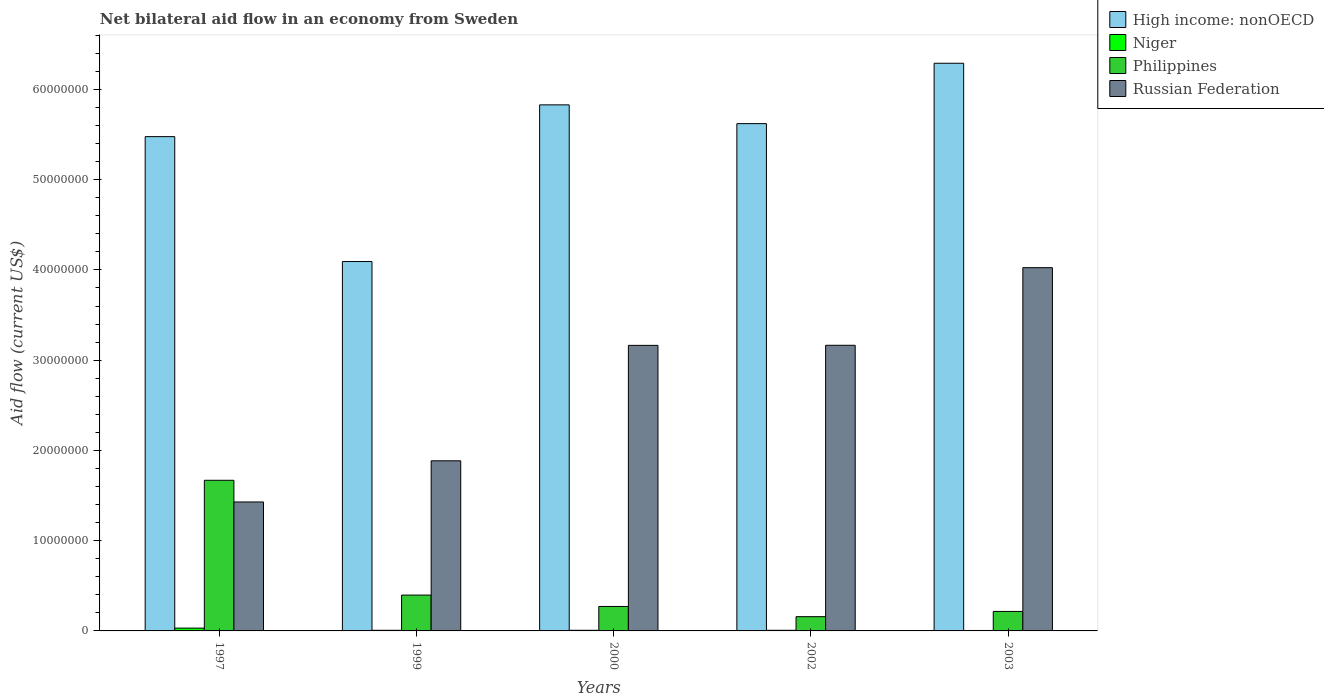In how many cases, is the number of bars for a given year not equal to the number of legend labels?
Your response must be concise. 0. What is the net bilateral aid flow in Russian Federation in 2002?
Give a very brief answer. 3.16e+07. Across all years, what is the maximum net bilateral aid flow in Russian Federation?
Your answer should be very brief. 4.02e+07. Across all years, what is the minimum net bilateral aid flow in Philippines?
Offer a terse response. 1.58e+06. In which year was the net bilateral aid flow in Niger minimum?
Provide a short and direct response. 2003. What is the total net bilateral aid flow in Philippines in the graph?
Offer a terse response. 2.71e+07. What is the difference between the net bilateral aid flow in High income: nonOECD in 1997 and that in 2002?
Your answer should be compact. -1.44e+06. What is the difference between the net bilateral aid flow in Russian Federation in 2000 and the net bilateral aid flow in Philippines in 2003?
Ensure brevity in your answer.  2.95e+07. What is the average net bilateral aid flow in Russian Federation per year?
Keep it short and to the point. 2.73e+07. In the year 2002, what is the difference between the net bilateral aid flow in Niger and net bilateral aid flow in High income: nonOECD?
Give a very brief answer. -5.61e+07. In how many years, is the net bilateral aid flow in Philippines greater than 18000000 US$?
Your answer should be very brief. 0. What is the ratio of the net bilateral aid flow in Russian Federation in 2000 to that in 2003?
Offer a very short reply. 0.79. What is the difference between the highest and the second highest net bilateral aid flow in Russian Federation?
Your response must be concise. 8.60e+06. What is the difference between the highest and the lowest net bilateral aid flow in High income: nonOECD?
Offer a terse response. 2.20e+07. Is the sum of the net bilateral aid flow in Russian Federation in 2002 and 2003 greater than the maximum net bilateral aid flow in Niger across all years?
Provide a succinct answer. Yes. What does the 1st bar from the left in 1997 represents?
Your answer should be very brief. High income: nonOECD. How many bars are there?
Ensure brevity in your answer.  20. What is the difference between two consecutive major ticks on the Y-axis?
Keep it short and to the point. 1.00e+07. Are the values on the major ticks of Y-axis written in scientific E-notation?
Give a very brief answer. No. Does the graph contain any zero values?
Give a very brief answer. No. Does the graph contain grids?
Offer a terse response. No. Where does the legend appear in the graph?
Provide a succinct answer. Top right. What is the title of the graph?
Offer a terse response. Net bilateral aid flow in an economy from Sweden. What is the Aid flow (current US$) in High income: nonOECD in 1997?
Keep it short and to the point. 5.48e+07. What is the Aid flow (current US$) in Niger in 1997?
Your answer should be compact. 3.10e+05. What is the Aid flow (current US$) in Philippines in 1997?
Keep it short and to the point. 1.67e+07. What is the Aid flow (current US$) of Russian Federation in 1997?
Your response must be concise. 1.43e+07. What is the Aid flow (current US$) in High income: nonOECD in 1999?
Keep it short and to the point. 4.09e+07. What is the Aid flow (current US$) of Philippines in 1999?
Provide a succinct answer. 3.97e+06. What is the Aid flow (current US$) in Russian Federation in 1999?
Keep it short and to the point. 1.88e+07. What is the Aid flow (current US$) of High income: nonOECD in 2000?
Offer a very short reply. 5.83e+07. What is the Aid flow (current US$) of Philippines in 2000?
Provide a short and direct response. 2.71e+06. What is the Aid flow (current US$) of Russian Federation in 2000?
Give a very brief answer. 3.16e+07. What is the Aid flow (current US$) of High income: nonOECD in 2002?
Ensure brevity in your answer.  5.62e+07. What is the Aid flow (current US$) of Niger in 2002?
Your answer should be very brief. 7.00e+04. What is the Aid flow (current US$) in Philippines in 2002?
Your response must be concise. 1.58e+06. What is the Aid flow (current US$) of Russian Federation in 2002?
Make the answer very short. 3.16e+07. What is the Aid flow (current US$) in High income: nonOECD in 2003?
Your answer should be compact. 6.29e+07. What is the Aid flow (current US$) in Niger in 2003?
Ensure brevity in your answer.  5.00e+04. What is the Aid flow (current US$) of Philippines in 2003?
Provide a succinct answer. 2.16e+06. What is the Aid flow (current US$) in Russian Federation in 2003?
Offer a terse response. 4.02e+07. Across all years, what is the maximum Aid flow (current US$) in High income: nonOECD?
Offer a terse response. 6.29e+07. Across all years, what is the maximum Aid flow (current US$) in Philippines?
Your answer should be compact. 1.67e+07. Across all years, what is the maximum Aid flow (current US$) of Russian Federation?
Ensure brevity in your answer.  4.02e+07. Across all years, what is the minimum Aid flow (current US$) in High income: nonOECD?
Your answer should be compact. 4.09e+07. Across all years, what is the minimum Aid flow (current US$) of Niger?
Offer a very short reply. 5.00e+04. Across all years, what is the minimum Aid flow (current US$) in Philippines?
Your answer should be very brief. 1.58e+06. Across all years, what is the minimum Aid flow (current US$) of Russian Federation?
Offer a very short reply. 1.43e+07. What is the total Aid flow (current US$) in High income: nonOECD in the graph?
Ensure brevity in your answer.  2.73e+08. What is the total Aid flow (current US$) in Niger in the graph?
Provide a short and direct response. 5.70e+05. What is the total Aid flow (current US$) in Philippines in the graph?
Keep it short and to the point. 2.71e+07. What is the total Aid flow (current US$) in Russian Federation in the graph?
Keep it short and to the point. 1.37e+08. What is the difference between the Aid flow (current US$) of High income: nonOECD in 1997 and that in 1999?
Ensure brevity in your answer.  1.38e+07. What is the difference between the Aid flow (current US$) of Philippines in 1997 and that in 1999?
Offer a very short reply. 1.27e+07. What is the difference between the Aid flow (current US$) in Russian Federation in 1997 and that in 1999?
Provide a succinct answer. -4.56e+06. What is the difference between the Aid flow (current US$) in High income: nonOECD in 1997 and that in 2000?
Offer a very short reply. -3.52e+06. What is the difference between the Aid flow (current US$) in Niger in 1997 and that in 2000?
Your answer should be compact. 2.40e+05. What is the difference between the Aid flow (current US$) of Philippines in 1997 and that in 2000?
Offer a terse response. 1.40e+07. What is the difference between the Aid flow (current US$) of Russian Federation in 1997 and that in 2000?
Offer a terse response. -1.74e+07. What is the difference between the Aid flow (current US$) of High income: nonOECD in 1997 and that in 2002?
Your response must be concise. -1.44e+06. What is the difference between the Aid flow (current US$) in Philippines in 1997 and that in 2002?
Your response must be concise. 1.51e+07. What is the difference between the Aid flow (current US$) of Russian Federation in 1997 and that in 2002?
Keep it short and to the point. -1.74e+07. What is the difference between the Aid flow (current US$) in High income: nonOECD in 1997 and that in 2003?
Provide a short and direct response. -8.13e+06. What is the difference between the Aid flow (current US$) in Philippines in 1997 and that in 2003?
Give a very brief answer. 1.45e+07. What is the difference between the Aid flow (current US$) in Russian Federation in 1997 and that in 2003?
Your response must be concise. -2.60e+07. What is the difference between the Aid flow (current US$) in High income: nonOECD in 1999 and that in 2000?
Provide a succinct answer. -1.74e+07. What is the difference between the Aid flow (current US$) of Philippines in 1999 and that in 2000?
Keep it short and to the point. 1.26e+06. What is the difference between the Aid flow (current US$) in Russian Federation in 1999 and that in 2000?
Give a very brief answer. -1.28e+07. What is the difference between the Aid flow (current US$) in High income: nonOECD in 1999 and that in 2002?
Your answer should be compact. -1.53e+07. What is the difference between the Aid flow (current US$) in Niger in 1999 and that in 2002?
Offer a terse response. 0. What is the difference between the Aid flow (current US$) of Philippines in 1999 and that in 2002?
Provide a succinct answer. 2.39e+06. What is the difference between the Aid flow (current US$) in Russian Federation in 1999 and that in 2002?
Your answer should be very brief. -1.28e+07. What is the difference between the Aid flow (current US$) in High income: nonOECD in 1999 and that in 2003?
Keep it short and to the point. -2.20e+07. What is the difference between the Aid flow (current US$) in Niger in 1999 and that in 2003?
Give a very brief answer. 2.00e+04. What is the difference between the Aid flow (current US$) in Philippines in 1999 and that in 2003?
Offer a terse response. 1.81e+06. What is the difference between the Aid flow (current US$) in Russian Federation in 1999 and that in 2003?
Make the answer very short. -2.14e+07. What is the difference between the Aid flow (current US$) of High income: nonOECD in 2000 and that in 2002?
Offer a very short reply. 2.08e+06. What is the difference between the Aid flow (current US$) in Philippines in 2000 and that in 2002?
Offer a very short reply. 1.13e+06. What is the difference between the Aid flow (current US$) of High income: nonOECD in 2000 and that in 2003?
Your answer should be compact. -4.61e+06. What is the difference between the Aid flow (current US$) in Niger in 2000 and that in 2003?
Make the answer very short. 2.00e+04. What is the difference between the Aid flow (current US$) of Philippines in 2000 and that in 2003?
Give a very brief answer. 5.50e+05. What is the difference between the Aid flow (current US$) in Russian Federation in 2000 and that in 2003?
Make the answer very short. -8.61e+06. What is the difference between the Aid flow (current US$) in High income: nonOECD in 2002 and that in 2003?
Offer a terse response. -6.69e+06. What is the difference between the Aid flow (current US$) of Niger in 2002 and that in 2003?
Your answer should be compact. 2.00e+04. What is the difference between the Aid flow (current US$) of Philippines in 2002 and that in 2003?
Ensure brevity in your answer.  -5.80e+05. What is the difference between the Aid flow (current US$) of Russian Federation in 2002 and that in 2003?
Your response must be concise. -8.60e+06. What is the difference between the Aid flow (current US$) in High income: nonOECD in 1997 and the Aid flow (current US$) in Niger in 1999?
Offer a terse response. 5.47e+07. What is the difference between the Aid flow (current US$) in High income: nonOECD in 1997 and the Aid flow (current US$) in Philippines in 1999?
Make the answer very short. 5.08e+07. What is the difference between the Aid flow (current US$) in High income: nonOECD in 1997 and the Aid flow (current US$) in Russian Federation in 1999?
Make the answer very short. 3.59e+07. What is the difference between the Aid flow (current US$) of Niger in 1997 and the Aid flow (current US$) of Philippines in 1999?
Your answer should be very brief. -3.66e+06. What is the difference between the Aid flow (current US$) in Niger in 1997 and the Aid flow (current US$) in Russian Federation in 1999?
Your answer should be compact. -1.85e+07. What is the difference between the Aid flow (current US$) in Philippines in 1997 and the Aid flow (current US$) in Russian Federation in 1999?
Keep it short and to the point. -2.16e+06. What is the difference between the Aid flow (current US$) in High income: nonOECD in 1997 and the Aid flow (current US$) in Niger in 2000?
Keep it short and to the point. 5.47e+07. What is the difference between the Aid flow (current US$) of High income: nonOECD in 1997 and the Aid flow (current US$) of Philippines in 2000?
Offer a terse response. 5.21e+07. What is the difference between the Aid flow (current US$) of High income: nonOECD in 1997 and the Aid flow (current US$) of Russian Federation in 2000?
Give a very brief answer. 2.31e+07. What is the difference between the Aid flow (current US$) of Niger in 1997 and the Aid flow (current US$) of Philippines in 2000?
Provide a succinct answer. -2.40e+06. What is the difference between the Aid flow (current US$) of Niger in 1997 and the Aid flow (current US$) of Russian Federation in 2000?
Offer a very short reply. -3.13e+07. What is the difference between the Aid flow (current US$) in Philippines in 1997 and the Aid flow (current US$) in Russian Federation in 2000?
Offer a very short reply. -1.50e+07. What is the difference between the Aid flow (current US$) of High income: nonOECD in 1997 and the Aid flow (current US$) of Niger in 2002?
Give a very brief answer. 5.47e+07. What is the difference between the Aid flow (current US$) in High income: nonOECD in 1997 and the Aid flow (current US$) in Philippines in 2002?
Make the answer very short. 5.32e+07. What is the difference between the Aid flow (current US$) of High income: nonOECD in 1997 and the Aid flow (current US$) of Russian Federation in 2002?
Your answer should be very brief. 2.31e+07. What is the difference between the Aid flow (current US$) of Niger in 1997 and the Aid flow (current US$) of Philippines in 2002?
Offer a terse response. -1.27e+06. What is the difference between the Aid flow (current US$) in Niger in 1997 and the Aid flow (current US$) in Russian Federation in 2002?
Your answer should be compact. -3.13e+07. What is the difference between the Aid flow (current US$) in Philippines in 1997 and the Aid flow (current US$) in Russian Federation in 2002?
Offer a terse response. -1.50e+07. What is the difference between the Aid flow (current US$) in High income: nonOECD in 1997 and the Aid flow (current US$) in Niger in 2003?
Offer a very short reply. 5.47e+07. What is the difference between the Aid flow (current US$) in High income: nonOECD in 1997 and the Aid flow (current US$) in Philippines in 2003?
Provide a short and direct response. 5.26e+07. What is the difference between the Aid flow (current US$) of High income: nonOECD in 1997 and the Aid flow (current US$) of Russian Federation in 2003?
Your answer should be very brief. 1.45e+07. What is the difference between the Aid flow (current US$) of Niger in 1997 and the Aid flow (current US$) of Philippines in 2003?
Provide a short and direct response. -1.85e+06. What is the difference between the Aid flow (current US$) of Niger in 1997 and the Aid flow (current US$) of Russian Federation in 2003?
Make the answer very short. -3.99e+07. What is the difference between the Aid flow (current US$) of Philippines in 1997 and the Aid flow (current US$) of Russian Federation in 2003?
Provide a short and direct response. -2.36e+07. What is the difference between the Aid flow (current US$) of High income: nonOECD in 1999 and the Aid flow (current US$) of Niger in 2000?
Provide a succinct answer. 4.09e+07. What is the difference between the Aid flow (current US$) in High income: nonOECD in 1999 and the Aid flow (current US$) in Philippines in 2000?
Offer a terse response. 3.82e+07. What is the difference between the Aid flow (current US$) of High income: nonOECD in 1999 and the Aid flow (current US$) of Russian Federation in 2000?
Your response must be concise. 9.29e+06. What is the difference between the Aid flow (current US$) of Niger in 1999 and the Aid flow (current US$) of Philippines in 2000?
Your response must be concise. -2.64e+06. What is the difference between the Aid flow (current US$) in Niger in 1999 and the Aid flow (current US$) in Russian Federation in 2000?
Your answer should be very brief. -3.16e+07. What is the difference between the Aid flow (current US$) in Philippines in 1999 and the Aid flow (current US$) in Russian Federation in 2000?
Provide a short and direct response. -2.77e+07. What is the difference between the Aid flow (current US$) of High income: nonOECD in 1999 and the Aid flow (current US$) of Niger in 2002?
Make the answer very short. 4.09e+07. What is the difference between the Aid flow (current US$) in High income: nonOECD in 1999 and the Aid flow (current US$) in Philippines in 2002?
Offer a very short reply. 3.94e+07. What is the difference between the Aid flow (current US$) of High income: nonOECD in 1999 and the Aid flow (current US$) of Russian Federation in 2002?
Offer a terse response. 9.28e+06. What is the difference between the Aid flow (current US$) in Niger in 1999 and the Aid flow (current US$) in Philippines in 2002?
Provide a short and direct response. -1.51e+06. What is the difference between the Aid flow (current US$) in Niger in 1999 and the Aid flow (current US$) in Russian Federation in 2002?
Provide a succinct answer. -3.16e+07. What is the difference between the Aid flow (current US$) in Philippines in 1999 and the Aid flow (current US$) in Russian Federation in 2002?
Ensure brevity in your answer.  -2.77e+07. What is the difference between the Aid flow (current US$) in High income: nonOECD in 1999 and the Aid flow (current US$) in Niger in 2003?
Give a very brief answer. 4.09e+07. What is the difference between the Aid flow (current US$) of High income: nonOECD in 1999 and the Aid flow (current US$) of Philippines in 2003?
Provide a short and direct response. 3.88e+07. What is the difference between the Aid flow (current US$) in High income: nonOECD in 1999 and the Aid flow (current US$) in Russian Federation in 2003?
Provide a short and direct response. 6.80e+05. What is the difference between the Aid flow (current US$) of Niger in 1999 and the Aid flow (current US$) of Philippines in 2003?
Make the answer very short. -2.09e+06. What is the difference between the Aid flow (current US$) in Niger in 1999 and the Aid flow (current US$) in Russian Federation in 2003?
Provide a succinct answer. -4.02e+07. What is the difference between the Aid flow (current US$) in Philippines in 1999 and the Aid flow (current US$) in Russian Federation in 2003?
Keep it short and to the point. -3.63e+07. What is the difference between the Aid flow (current US$) of High income: nonOECD in 2000 and the Aid flow (current US$) of Niger in 2002?
Your answer should be very brief. 5.82e+07. What is the difference between the Aid flow (current US$) in High income: nonOECD in 2000 and the Aid flow (current US$) in Philippines in 2002?
Provide a succinct answer. 5.67e+07. What is the difference between the Aid flow (current US$) of High income: nonOECD in 2000 and the Aid flow (current US$) of Russian Federation in 2002?
Offer a terse response. 2.66e+07. What is the difference between the Aid flow (current US$) of Niger in 2000 and the Aid flow (current US$) of Philippines in 2002?
Offer a terse response. -1.51e+06. What is the difference between the Aid flow (current US$) in Niger in 2000 and the Aid flow (current US$) in Russian Federation in 2002?
Provide a succinct answer. -3.16e+07. What is the difference between the Aid flow (current US$) of Philippines in 2000 and the Aid flow (current US$) of Russian Federation in 2002?
Ensure brevity in your answer.  -2.89e+07. What is the difference between the Aid flow (current US$) in High income: nonOECD in 2000 and the Aid flow (current US$) in Niger in 2003?
Provide a succinct answer. 5.82e+07. What is the difference between the Aid flow (current US$) of High income: nonOECD in 2000 and the Aid flow (current US$) of Philippines in 2003?
Give a very brief answer. 5.61e+07. What is the difference between the Aid flow (current US$) in High income: nonOECD in 2000 and the Aid flow (current US$) in Russian Federation in 2003?
Keep it short and to the point. 1.80e+07. What is the difference between the Aid flow (current US$) of Niger in 2000 and the Aid flow (current US$) of Philippines in 2003?
Make the answer very short. -2.09e+06. What is the difference between the Aid flow (current US$) in Niger in 2000 and the Aid flow (current US$) in Russian Federation in 2003?
Offer a terse response. -4.02e+07. What is the difference between the Aid flow (current US$) of Philippines in 2000 and the Aid flow (current US$) of Russian Federation in 2003?
Make the answer very short. -3.75e+07. What is the difference between the Aid flow (current US$) in High income: nonOECD in 2002 and the Aid flow (current US$) in Niger in 2003?
Ensure brevity in your answer.  5.62e+07. What is the difference between the Aid flow (current US$) of High income: nonOECD in 2002 and the Aid flow (current US$) of Philippines in 2003?
Your answer should be compact. 5.40e+07. What is the difference between the Aid flow (current US$) of High income: nonOECD in 2002 and the Aid flow (current US$) of Russian Federation in 2003?
Your answer should be compact. 1.60e+07. What is the difference between the Aid flow (current US$) in Niger in 2002 and the Aid flow (current US$) in Philippines in 2003?
Give a very brief answer. -2.09e+06. What is the difference between the Aid flow (current US$) of Niger in 2002 and the Aid flow (current US$) of Russian Federation in 2003?
Your response must be concise. -4.02e+07. What is the difference between the Aid flow (current US$) in Philippines in 2002 and the Aid flow (current US$) in Russian Federation in 2003?
Offer a very short reply. -3.87e+07. What is the average Aid flow (current US$) of High income: nonOECD per year?
Ensure brevity in your answer.  5.46e+07. What is the average Aid flow (current US$) of Niger per year?
Offer a very short reply. 1.14e+05. What is the average Aid flow (current US$) of Philippines per year?
Ensure brevity in your answer.  5.42e+06. What is the average Aid flow (current US$) of Russian Federation per year?
Ensure brevity in your answer.  2.73e+07. In the year 1997, what is the difference between the Aid flow (current US$) in High income: nonOECD and Aid flow (current US$) in Niger?
Your response must be concise. 5.45e+07. In the year 1997, what is the difference between the Aid flow (current US$) of High income: nonOECD and Aid flow (current US$) of Philippines?
Offer a very short reply. 3.81e+07. In the year 1997, what is the difference between the Aid flow (current US$) of High income: nonOECD and Aid flow (current US$) of Russian Federation?
Provide a succinct answer. 4.05e+07. In the year 1997, what is the difference between the Aid flow (current US$) of Niger and Aid flow (current US$) of Philippines?
Your answer should be compact. -1.64e+07. In the year 1997, what is the difference between the Aid flow (current US$) in Niger and Aid flow (current US$) in Russian Federation?
Provide a short and direct response. -1.40e+07. In the year 1997, what is the difference between the Aid flow (current US$) in Philippines and Aid flow (current US$) in Russian Federation?
Make the answer very short. 2.40e+06. In the year 1999, what is the difference between the Aid flow (current US$) of High income: nonOECD and Aid flow (current US$) of Niger?
Give a very brief answer. 4.09e+07. In the year 1999, what is the difference between the Aid flow (current US$) of High income: nonOECD and Aid flow (current US$) of Philippines?
Offer a very short reply. 3.70e+07. In the year 1999, what is the difference between the Aid flow (current US$) in High income: nonOECD and Aid flow (current US$) in Russian Federation?
Make the answer very short. 2.21e+07. In the year 1999, what is the difference between the Aid flow (current US$) in Niger and Aid flow (current US$) in Philippines?
Make the answer very short. -3.90e+06. In the year 1999, what is the difference between the Aid flow (current US$) of Niger and Aid flow (current US$) of Russian Federation?
Your answer should be compact. -1.88e+07. In the year 1999, what is the difference between the Aid flow (current US$) of Philippines and Aid flow (current US$) of Russian Federation?
Your answer should be compact. -1.49e+07. In the year 2000, what is the difference between the Aid flow (current US$) of High income: nonOECD and Aid flow (current US$) of Niger?
Your answer should be very brief. 5.82e+07. In the year 2000, what is the difference between the Aid flow (current US$) of High income: nonOECD and Aid flow (current US$) of Philippines?
Provide a succinct answer. 5.56e+07. In the year 2000, what is the difference between the Aid flow (current US$) in High income: nonOECD and Aid flow (current US$) in Russian Federation?
Keep it short and to the point. 2.66e+07. In the year 2000, what is the difference between the Aid flow (current US$) in Niger and Aid flow (current US$) in Philippines?
Ensure brevity in your answer.  -2.64e+06. In the year 2000, what is the difference between the Aid flow (current US$) of Niger and Aid flow (current US$) of Russian Federation?
Your answer should be compact. -3.16e+07. In the year 2000, what is the difference between the Aid flow (current US$) of Philippines and Aid flow (current US$) of Russian Federation?
Provide a succinct answer. -2.89e+07. In the year 2002, what is the difference between the Aid flow (current US$) of High income: nonOECD and Aid flow (current US$) of Niger?
Keep it short and to the point. 5.61e+07. In the year 2002, what is the difference between the Aid flow (current US$) of High income: nonOECD and Aid flow (current US$) of Philippines?
Keep it short and to the point. 5.46e+07. In the year 2002, what is the difference between the Aid flow (current US$) in High income: nonOECD and Aid flow (current US$) in Russian Federation?
Your answer should be compact. 2.46e+07. In the year 2002, what is the difference between the Aid flow (current US$) in Niger and Aid flow (current US$) in Philippines?
Keep it short and to the point. -1.51e+06. In the year 2002, what is the difference between the Aid flow (current US$) of Niger and Aid flow (current US$) of Russian Federation?
Provide a short and direct response. -3.16e+07. In the year 2002, what is the difference between the Aid flow (current US$) in Philippines and Aid flow (current US$) in Russian Federation?
Give a very brief answer. -3.01e+07. In the year 2003, what is the difference between the Aid flow (current US$) of High income: nonOECD and Aid flow (current US$) of Niger?
Provide a succinct answer. 6.28e+07. In the year 2003, what is the difference between the Aid flow (current US$) in High income: nonOECD and Aid flow (current US$) in Philippines?
Make the answer very short. 6.07e+07. In the year 2003, what is the difference between the Aid flow (current US$) of High income: nonOECD and Aid flow (current US$) of Russian Federation?
Ensure brevity in your answer.  2.26e+07. In the year 2003, what is the difference between the Aid flow (current US$) of Niger and Aid flow (current US$) of Philippines?
Make the answer very short. -2.11e+06. In the year 2003, what is the difference between the Aid flow (current US$) in Niger and Aid flow (current US$) in Russian Federation?
Your answer should be compact. -4.02e+07. In the year 2003, what is the difference between the Aid flow (current US$) of Philippines and Aid flow (current US$) of Russian Federation?
Your response must be concise. -3.81e+07. What is the ratio of the Aid flow (current US$) of High income: nonOECD in 1997 to that in 1999?
Offer a very short reply. 1.34. What is the ratio of the Aid flow (current US$) in Niger in 1997 to that in 1999?
Ensure brevity in your answer.  4.43. What is the ratio of the Aid flow (current US$) of Philippines in 1997 to that in 1999?
Your answer should be very brief. 4.2. What is the ratio of the Aid flow (current US$) of Russian Federation in 1997 to that in 1999?
Provide a short and direct response. 0.76. What is the ratio of the Aid flow (current US$) in High income: nonOECD in 1997 to that in 2000?
Your answer should be very brief. 0.94. What is the ratio of the Aid flow (current US$) in Niger in 1997 to that in 2000?
Your answer should be very brief. 4.43. What is the ratio of the Aid flow (current US$) of Philippines in 1997 to that in 2000?
Make the answer very short. 6.16. What is the ratio of the Aid flow (current US$) in Russian Federation in 1997 to that in 2000?
Offer a very short reply. 0.45. What is the ratio of the Aid flow (current US$) of High income: nonOECD in 1997 to that in 2002?
Make the answer very short. 0.97. What is the ratio of the Aid flow (current US$) of Niger in 1997 to that in 2002?
Offer a terse response. 4.43. What is the ratio of the Aid flow (current US$) of Philippines in 1997 to that in 2002?
Your answer should be very brief. 10.56. What is the ratio of the Aid flow (current US$) in Russian Federation in 1997 to that in 2002?
Provide a succinct answer. 0.45. What is the ratio of the Aid flow (current US$) of High income: nonOECD in 1997 to that in 2003?
Offer a very short reply. 0.87. What is the ratio of the Aid flow (current US$) in Niger in 1997 to that in 2003?
Your answer should be very brief. 6.2. What is the ratio of the Aid flow (current US$) of Philippines in 1997 to that in 2003?
Offer a terse response. 7.73. What is the ratio of the Aid flow (current US$) of Russian Federation in 1997 to that in 2003?
Offer a very short reply. 0.35. What is the ratio of the Aid flow (current US$) in High income: nonOECD in 1999 to that in 2000?
Give a very brief answer. 0.7. What is the ratio of the Aid flow (current US$) of Niger in 1999 to that in 2000?
Offer a very short reply. 1. What is the ratio of the Aid flow (current US$) in Philippines in 1999 to that in 2000?
Provide a short and direct response. 1.46. What is the ratio of the Aid flow (current US$) in Russian Federation in 1999 to that in 2000?
Ensure brevity in your answer.  0.6. What is the ratio of the Aid flow (current US$) of High income: nonOECD in 1999 to that in 2002?
Your response must be concise. 0.73. What is the ratio of the Aid flow (current US$) in Philippines in 1999 to that in 2002?
Ensure brevity in your answer.  2.51. What is the ratio of the Aid flow (current US$) in Russian Federation in 1999 to that in 2002?
Your answer should be very brief. 0.6. What is the ratio of the Aid flow (current US$) in High income: nonOECD in 1999 to that in 2003?
Provide a short and direct response. 0.65. What is the ratio of the Aid flow (current US$) in Niger in 1999 to that in 2003?
Offer a very short reply. 1.4. What is the ratio of the Aid flow (current US$) of Philippines in 1999 to that in 2003?
Offer a very short reply. 1.84. What is the ratio of the Aid flow (current US$) of Russian Federation in 1999 to that in 2003?
Ensure brevity in your answer.  0.47. What is the ratio of the Aid flow (current US$) of Philippines in 2000 to that in 2002?
Your answer should be very brief. 1.72. What is the ratio of the Aid flow (current US$) of Russian Federation in 2000 to that in 2002?
Keep it short and to the point. 1. What is the ratio of the Aid flow (current US$) in High income: nonOECD in 2000 to that in 2003?
Ensure brevity in your answer.  0.93. What is the ratio of the Aid flow (current US$) of Philippines in 2000 to that in 2003?
Provide a short and direct response. 1.25. What is the ratio of the Aid flow (current US$) of Russian Federation in 2000 to that in 2003?
Your answer should be very brief. 0.79. What is the ratio of the Aid flow (current US$) of High income: nonOECD in 2002 to that in 2003?
Your response must be concise. 0.89. What is the ratio of the Aid flow (current US$) of Philippines in 2002 to that in 2003?
Offer a very short reply. 0.73. What is the ratio of the Aid flow (current US$) of Russian Federation in 2002 to that in 2003?
Offer a very short reply. 0.79. What is the difference between the highest and the second highest Aid flow (current US$) of High income: nonOECD?
Ensure brevity in your answer.  4.61e+06. What is the difference between the highest and the second highest Aid flow (current US$) of Philippines?
Your answer should be compact. 1.27e+07. What is the difference between the highest and the second highest Aid flow (current US$) in Russian Federation?
Offer a very short reply. 8.60e+06. What is the difference between the highest and the lowest Aid flow (current US$) in High income: nonOECD?
Your response must be concise. 2.20e+07. What is the difference between the highest and the lowest Aid flow (current US$) of Niger?
Offer a terse response. 2.60e+05. What is the difference between the highest and the lowest Aid flow (current US$) in Philippines?
Your answer should be compact. 1.51e+07. What is the difference between the highest and the lowest Aid flow (current US$) of Russian Federation?
Your response must be concise. 2.60e+07. 